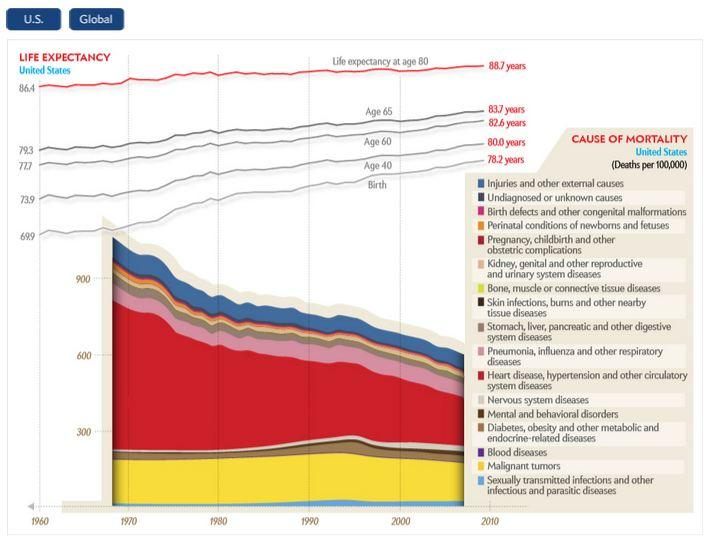Give some essential details in this illustration. The color that represents the highest mortality rate in the United States is red. The count of the leading causes of mortality in the United States is 17, according to recent data. 